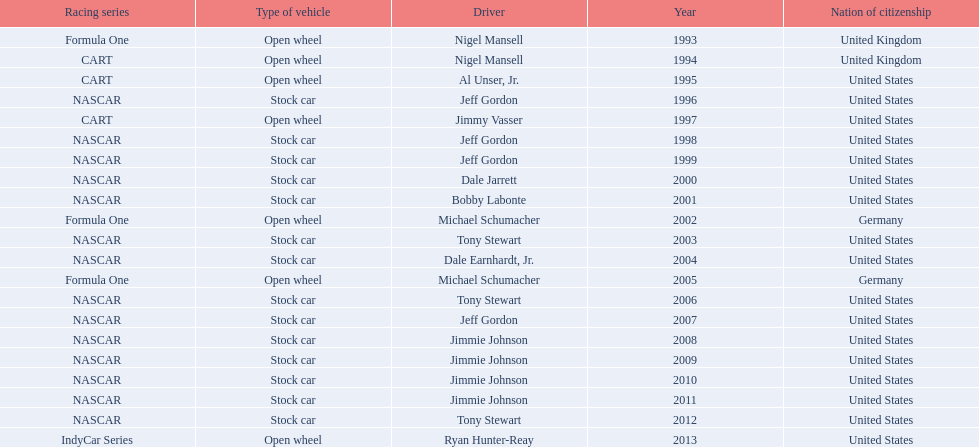What year(s) did nigel mansel receive epsy awards? 1993, 1994. What year(s) did michael schumacher receive epsy awards? 2002, 2005. What year(s) did jeff gordon receive epsy awards? 1996, 1998, 1999, 2007. What year(s) did al unser jr. receive epsy awards? 1995. Which driver only received one epsy award? Al Unser, Jr. 